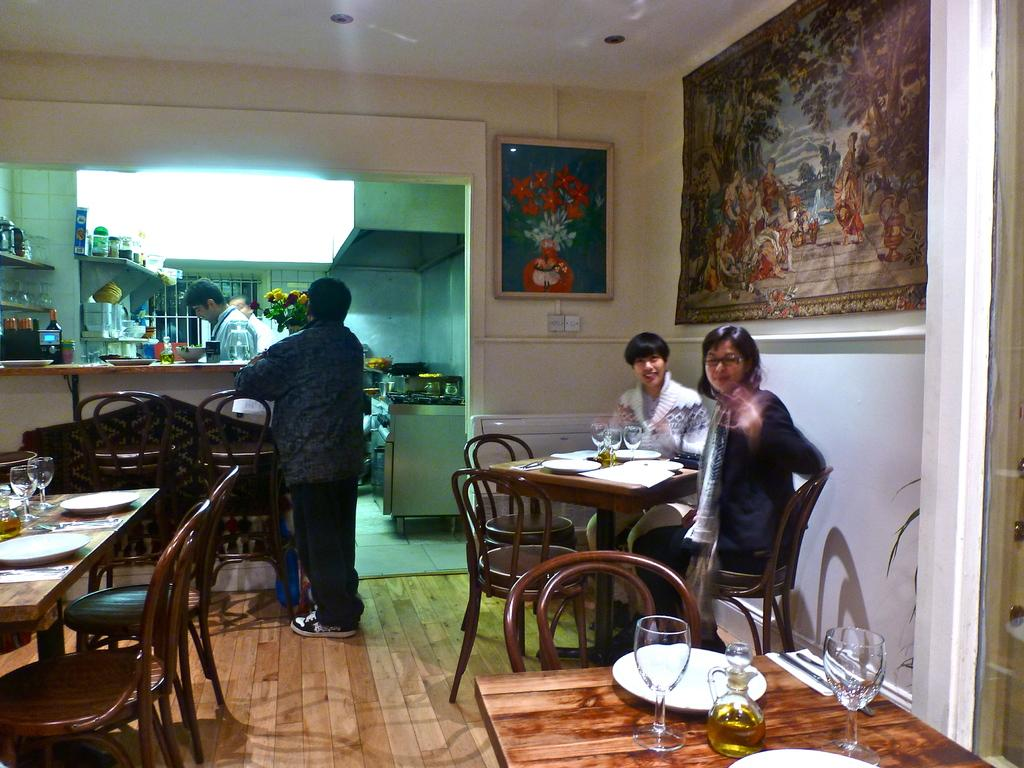What are the people in the image doing? There are people sitting on chairs and people standing in the image. Can you describe the positions of the people in the image? Some people are sitting on chairs, while others are standing. What type of plough is being used by the aunt in the image? There is no aunt or plough present in the image. 